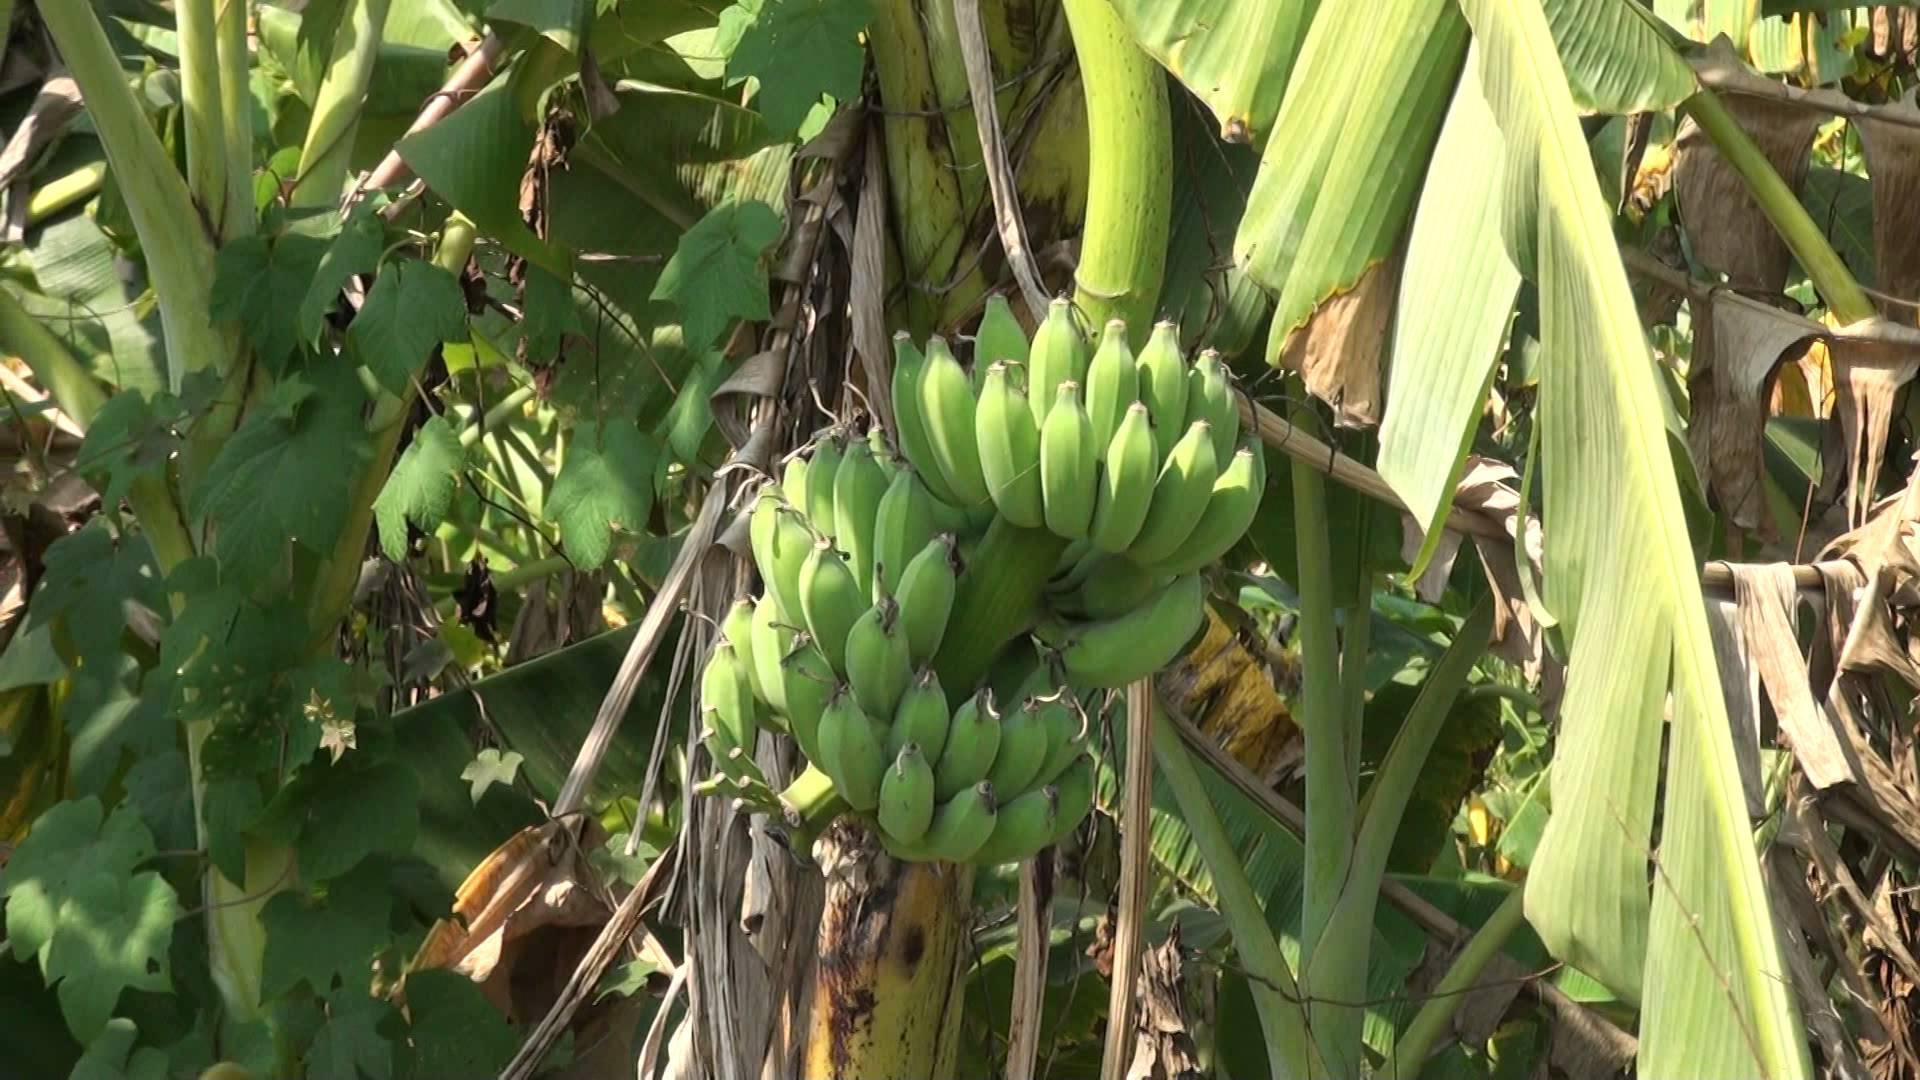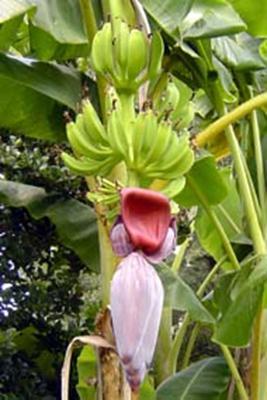The first image is the image on the left, the second image is the image on the right. Assess this claim about the two images: "The righthand image shows a big purple flower with red underside of a petal visible below a bunch of green bananas, but the left image does not show any red undersides of petals.". Correct or not? Answer yes or no. Yes. The first image is the image on the left, the second image is the image on the right. Assess this claim about the two images: "The image to the right is focused on the red flowering bottom of a banana bunch.". Correct or not? Answer yes or no. Yes. 